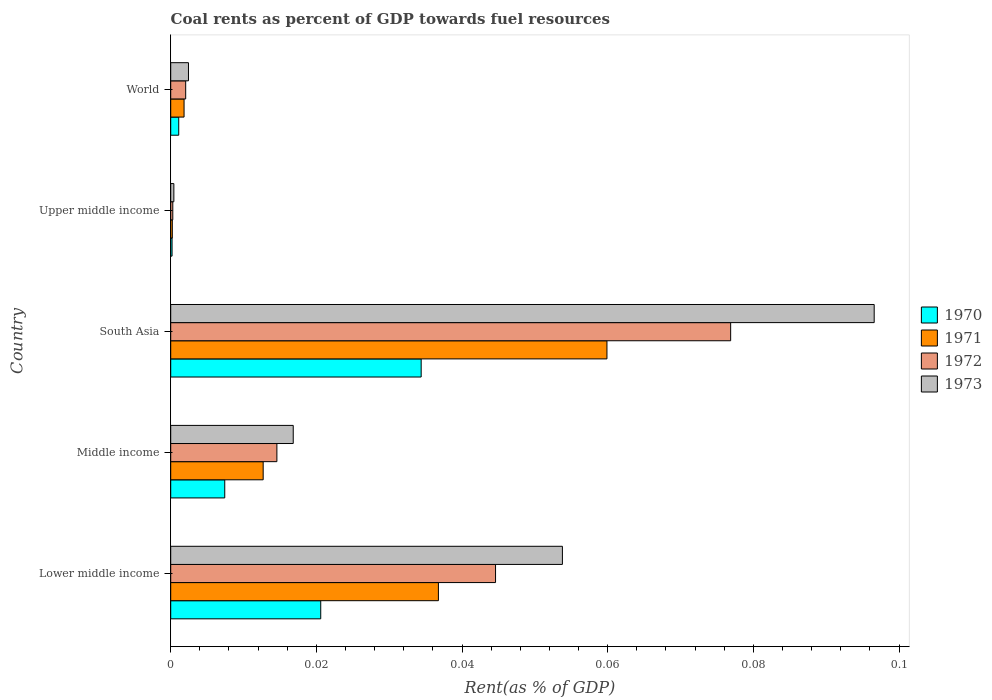Are the number of bars per tick equal to the number of legend labels?
Give a very brief answer. Yes. How many bars are there on the 5th tick from the top?
Your answer should be compact. 4. What is the label of the 2nd group of bars from the top?
Keep it short and to the point. Upper middle income. What is the coal rent in 1971 in World?
Make the answer very short. 0. Across all countries, what is the maximum coal rent in 1970?
Keep it short and to the point. 0.03. Across all countries, what is the minimum coal rent in 1972?
Your response must be concise. 0. In which country was the coal rent in 1972 minimum?
Your answer should be compact. Upper middle income. What is the total coal rent in 1973 in the graph?
Your response must be concise. 0.17. What is the difference between the coal rent in 1970 in Middle income and that in South Asia?
Ensure brevity in your answer.  -0.03. What is the difference between the coal rent in 1970 in Lower middle income and the coal rent in 1971 in Upper middle income?
Your answer should be compact. 0.02. What is the average coal rent in 1972 per country?
Provide a short and direct response. 0.03. What is the difference between the coal rent in 1972 and coal rent in 1970 in Lower middle income?
Your response must be concise. 0.02. In how many countries, is the coal rent in 1973 greater than 0.088 %?
Keep it short and to the point. 1. What is the ratio of the coal rent in 1971 in Middle income to that in South Asia?
Provide a short and direct response. 0.21. What is the difference between the highest and the second highest coal rent in 1971?
Your response must be concise. 0.02. What is the difference between the highest and the lowest coal rent in 1972?
Keep it short and to the point. 0.08. In how many countries, is the coal rent in 1970 greater than the average coal rent in 1970 taken over all countries?
Your answer should be compact. 2. Is the sum of the coal rent in 1971 in Middle income and Upper middle income greater than the maximum coal rent in 1973 across all countries?
Your answer should be compact. No. Is it the case that in every country, the sum of the coal rent in 1970 and coal rent in 1972 is greater than the coal rent in 1971?
Your answer should be very brief. Yes. Are the values on the major ticks of X-axis written in scientific E-notation?
Give a very brief answer. No. How many legend labels are there?
Keep it short and to the point. 4. How are the legend labels stacked?
Give a very brief answer. Vertical. What is the title of the graph?
Provide a short and direct response. Coal rents as percent of GDP towards fuel resources. Does "1972" appear as one of the legend labels in the graph?
Your answer should be compact. Yes. What is the label or title of the X-axis?
Your answer should be very brief. Rent(as % of GDP). What is the Rent(as % of GDP) in 1970 in Lower middle income?
Provide a short and direct response. 0.02. What is the Rent(as % of GDP) in 1971 in Lower middle income?
Offer a very short reply. 0.04. What is the Rent(as % of GDP) in 1972 in Lower middle income?
Your answer should be compact. 0.04. What is the Rent(as % of GDP) in 1973 in Lower middle income?
Ensure brevity in your answer.  0.05. What is the Rent(as % of GDP) in 1970 in Middle income?
Offer a very short reply. 0.01. What is the Rent(as % of GDP) in 1971 in Middle income?
Ensure brevity in your answer.  0.01. What is the Rent(as % of GDP) of 1972 in Middle income?
Your answer should be compact. 0.01. What is the Rent(as % of GDP) of 1973 in Middle income?
Make the answer very short. 0.02. What is the Rent(as % of GDP) in 1970 in South Asia?
Keep it short and to the point. 0.03. What is the Rent(as % of GDP) in 1971 in South Asia?
Your answer should be very brief. 0.06. What is the Rent(as % of GDP) of 1972 in South Asia?
Make the answer very short. 0.08. What is the Rent(as % of GDP) in 1973 in South Asia?
Give a very brief answer. 0.1. What is the Rent(as % of GDP) of 1970 in Upper middle income?
Offer a very short reply. 0. What is the Rent(as % of GDP) in 1971 in Upper middle income?
Offer a terse response. 0. What is the Rent(as % of GDP) of 1972 in Upper middle income?
Your answer should be very brief. 0. What is the Rent(as % of GDP) of 1973 in Upper middle income?
Offer a terse response. 0. What is the Rent(as % of GDP) of 1970 in World?
Your answer should be compact. 0. What is the Rent(as % of GDP) of 1971 in World?
Offer a terse response. 0. What is the Rent(as % of GDP) in 1972 in World?
Keep it short and to the point. 0. What is the Rent(as % of GDP) in 1973 in World?
Your response must be concise. 0. Across all countries, what is the maximum Rent(as % of GDP) of 1970?
Your response must be concise. 0.03. Across all countries, what is the maximum Rent(as % of GDP) of 1971?
Provide a short and direct response. 0.06. Across all countries, what is the maximum Rent(as % of GDP) of 1972?
Make the answer very short. 0.08. Across all countries, what is the maximum Rent(as % of GDP) of 1973?
Your answer should be compact. 0.1. Across all countries, what is the minimum Rent(as % of GDP) in 1970?
Ensure brevity in your answer.  0. Across all countries, what is the minimum Rent(as % of GDP) of 1971?
Make the answer very short. 0. Across all countries, what is the minimum Rent(as % of GDP) in 1972?
Offer a terse response. 0. Across all countries, what is the minimum Rent(as % of GDP) of 1973?
Make the answer very short. 0. What is the total Rent(as % of GDP) of 1970 in the graph?
Your answer should be compact. 0.06. What is the total Rent(as % of GDP) in 1971 in the graph?
Your response must be concise. 0.11. What is the total Rent(as % of GDP) in 1972 in the graph?
Your answer should be compact. 0.14. What is the total Rent(as % of GDP) in 1973 in the graph?
Provide a succinct answer. 0.17. What is the difference between the Rent(as % of GDP) of 1970 in Lower middle income and that in Middle income?
Provide a succinct answer. 0.01. What is the difference between the Rent(as % of GDP) of 1971 in Lower middle income and that in Middle income?
Keep it short and to the point. 0.02. What is the difference between the Rent(as % of GDP) in 1972 in Lower middle income and that in Middle income?
Provide a short and direct response. 0.03. What is the difference between the Rent(as % of GDP) of 1973 in Lower middle income and that in Middle income?
Your answer should be very brief. 0.04. What is the difference between the Rent(as % of GDP) of 1970 in Lower middle income and that in South Asia?
Give a very brief answer. -0.01. What is the difference between the Rent(as % of GDP) of 1971 in Lower middle income and that in South Asia?
Your answer should be compact. -0.02. What is the difference between the Rent(as % of GDP) in 1972 in Lower middle income and that in South Asia?
Offer a terse response. -0.03. What is the difference between the Rent(as % of GDP) in 1973 in Lower middle income and that in South Asia?
Your response must be concise. -0.04. What is the difference between the Rent(as % of GDP) of 1970 in Lower middle income and that in Upper middle income?
Provide a short and direct response. 0.02. What is the difference between the Rent(as % of GDP) of 1971 in Lower middle income and that in Upper middle income?
Ensure brevity in your answer.  0.04. What is the difference between the Rent(as % of GDP) of 1972 in Lower middle income and that in Upper middle income?
Provide a succinct answer. 0.04. What is the difference between the Rent(as % of GDP) in 1973 in Lower middle income and that in Upper middle income?
Offer a terse response. 0.05. What is the difference between the Rent(as % of GDP) of 1970 in Lower middle income and that in World?
Your answer should be very brief. 0.02. What is the difference between the Rent(as % of GDP) in 1971 in Lower middle income and that in World?
Your answer should be compact. 0.03. What is the difference between the Rent(as % of GDP) in 1972 in Lower middle income and that in World?
Provide a succinct answer. 0.04. What is the difference between the Rent(as % of GDP) in 1973 in Lower middle income and that in World?
Make the answer very short. 0.05. What is the difference between the Rent(as % of GDP) of 1970 in Middle income and that in South Asia?
Give a very brief answer. -0.03. What is the difference between the Rent(as % of GDP) in 1971 in Middle income and that in South Asia?
Your answer should be compact. -0.05. What is the difference between the Rent(as % of GDP) in 1972 in Middle income and that in South Asia?
Offer a very short reply. -0.06. What is the difference between the Rent(as % of GDP) of 1973 in Middle income and that in South Asia?
Give a very brief answer. -0.08. What is the difference between the Rent(as % of GDP) of 1970 in Middle income and that in Upper middle income?
Your answer should be compact. 0.01. What is the difference between the Rent(as % of GDP) of 1971 in Middle income and that in Upper middle income?
Your answer should be compact. 0.01. What is the difference between the Rent(as % of GDP) in 1972 in Middle income and that in Upper middle income?
Your response must be concise. 0.01. What is the difference between the Rent(as % of GDP) of 1973 in Middle income and that in Upper middle income?
Your response must be concise. 0.02. What is the difference between the Rent(as % of GDP) in 1970 in Middle income and that in World?
Offer a very short reply. 0.01. What is the difference between the Rent(as % of GDP) of 1971 in Middle income and that in World?
Your answer should be very brief. 0.01. What is the difference between the Rent(as % of GDP) in 1972 in Middle income and that in World?
Provide a short and direct response. 0.01. What is the difference between the Rent(as % of GDP) in 1973 in Middle income and that in World?
Your answer should be compact. 0.01. What is the difference between the Rent(as % of GDP) in 1970 in South Asia and that in Upper middle income?
Your response must be concise. 0.03. What is the difference between the Rent(as % of GDP) of 1971 in South Asia and that in Upper middle income?
Ensure brevity in your answer.  0.06. What is the difference between the Rent(as % of GDP) of 1972 in South Asia and that in Upper middle income?
Offer a terse response. 0.08. What is the difference between the Rent(as % of GDP) in 1973 in South Asia and that in Upper middle income?
Provide a short and direct response. 0.1. What is the difference between the Rent(as % of GDP) of 1971 in South Asia and that in World?
Give a very brief answer. 0.06. What is the difference between the Rent(as % of GDP) of 1972 in South Asia and that in World?
Offer a very short reply. 0.07. What is the difference between the Rent(as % of GDP) of 1973 in South Asia and that in World?
Offer a very short reply. 0.09. What is the difference between the Rent(as % of GDP) of 1970 in Upper middle income and that in World?
Your response must be concise. -0. What is the difference between the Rent(as % of GDP) of 1971 in Upper middle income and that in World?
Offer a very short reply. -0. What is the difference between the Rent(as % of GDP) in 1972 in Upper middle income and that in World?
Your answer should be very brief. -0. What is the difference between the Rent(as % of GDP) in 1973 in Upper middle income and that in World?
Your answer should be compact. -0. What is the difference between the Rent(as % of GDP) in 1970 in Lower middle income and the Rent(as % of GDP) in 1971 in Middle income?
Offer a very short reply. 0.01. What is the difference between the Rent(as % of GDP) of 1970 in Lower middle income and the Rent(as % of GDP) of 1972 in Middle income?
Provide a short and direct response. 0.01. What is the difference between the Rent(as % of GDP) of 1970 in Lower middle income and the Rent(as % of GDP) of 1973 in Middle income?
Keep it short and to the point. 0. What is the difference between the Rent(as % of GDP) of 1971 in Lower middle income and the Rent(as % of GDP) of 1972 in Middle income?
Give a very brief answer. 0.02. What is the difference between the Rent(as % of GDP) in 1971 in Lower middle income and the Rent(as % of GDP) in 1973 in Middle income?
Give a very brief answer. 0.02. What is the difference between the Rent(as % of GDP) of 1972 in Lower middle income and the Rent(as % of GDP) of 1973 in Middle income?
Your answer should be compact. 0.03. What is the difference between the Rent(as % of GDP) in 1970 in Lower middle income and the Rent(as % of GDP) in 1971 in South Asia?
Your response must be concise. -0.04. What is the difference between the Rent(as % of GDP) in 1970 in Lower middle income and the Rent(as % of GDP) in 1972 in South Asia?
Provide a short and direct response. -0.06. What is the difference between the Rent(as % of GDP) of 1970 in Lower middle income and the Rent(as % of GDP) of 1973 in South Asia?
Provide a succinct answer. -0.08. What is the difference between the Rent(as % of GDP) of 1971 in Lower middle income and the Rent(as % of GDP) of 1972 in South Asia?
Make the answer very short. -0.04. What is the difference between the Rent(as % of GDP) of 1971 in Lower middle income and the Rent(as % of GDP) of 1973 in South Asia?
Keep it short and to the point. -0.06. What is the difference between the Rent(as % of GDP) of 1972 in Lower middle income and the Rent(as % of GDP) of 1973 in South Asia?
Your answer should be compact. -0.05. What is the difference between the Rent(as % of GDP) in 1970 in Lower middle income and the Rent(as % of GDP) in 1971 in Upper middle income?
Your response must be concise. 0.02. What is the difference between the Rent(as % of GDP) of 1970 in Lower middle income and the Rent(as % of GDP) of 1972 in Upper middle income?
Keep it short and to the point. 0.02. What is the difference between the Rent(as % of GDP) in 1970 in Lower middle income and the Rent(as % of GDP) in 1973 in Upper middle income?
Your response must be concise. 0.02. What is the difference between the Rent(as % of GDP) of 1971 in Lower middle income and the Rent(as % of GDP) of 1972 in Upper middle income?
Keep it short and to the point. 0.04. What is the difference between the Rent(as % of GDP) of 1971 in Lower middle income and the Rent(as % of GDP) of 1973 in Upper middle income?
Your answer should be compact. 0.04. What is the difference between the Rent(as % of GDP) of 1972 in Lower middle income and the Rent(as % of GDP) of 1973 in Upper middle income?
Your response must be concise. 0.04. What is the difference between the Rent(as % of GDP) in 1970 in Lower middle income and the Rent(as % of GDP) in 1971 in World?
Your response must be concise. 0.02. What is the difference between the Rent(as % of GDP) in 1970 in Lower middle income and the Rent(as % of GDP) in 1972 in World?
Offer a terse response. 0.02. What is the difference between the Rent(as % of GDP) of 1970 in Lower middle income and the Rent(as % of GDP) of 1973 in World?
Your answer should be compact. 0.02. What is the difference between the Rent(as % of GDP) in 1971 in Lower middle income and the Rent(as % of GDP) in 1972 in World?
Keep it short and to the point. 0.03. What is the difference between the Rent(as % of GDP) of 1971 in Lower middle income and the Rent(as % of GDP) of 1973 in World?
Provide a succinct answer. 0.03. What is the difference between the Rent(as % of GDP) of 1972 in Lower middle income and the Rent(as % of GDP) of 1973 in World?
Your answer should be very brief. 0.04. What is the difference between the Rent(as % of GDP) in 1970 in Middle income and the Rent(as % of GDP) in 1971 in South Asia?
Offer a terse response. -0.05. What is the difference between the Rent(as % of GDP) in 1970 in Middle income and the Rent(as % of GDP) in 1972 in South Asia?
Your answer should be very brief. -0.07. What is the difference between the Rent(as % of GDP) in 1970 in Middle income and the Rent(as % of GDP) in 1973 in South Asia?
Offer a very short reply. -0.09. What is the difference between the Rent(as % of GDP) of 1971 in Middle income and the Rent(as % of GDP) of 1972 in South Asia?
Ensure brevity in your answer.  -0.06. What is the difference between the Rent(as % of GDP) of 1971 in Middle income and the Rent(as % of GDP) of 1973 in South Asia?
Keep it short and to the point. -0.08. What is the difference between the Rent(as % of GDP) in 1972 in Middle income and the Rent(as % of GDP) in 1973 in South Asia?
Your answer should be compact. -0.08. What is the difference between the Rent(as % of GDP) in 1970 in Middle income and the Rent(as % of GDP) in 1971 in Upper middle income?
Keep it short and to the point. 0.01. What is the difference between the Rent(as % of GDP) in 1970 in Middle income and the Rent(as % of GDP) in 1972 in Upper middle income?
Offer a very short reply. 0.01. What is the difference between the Rent(as % of GDP) in 1970 in Middle income and the Rent(as % of GDP) in 1973 in Upper middle income?
Keep it short and to the point. 0.01. What is the difference between the Rent(as % of GDP) in 1971 in Middle income and the Rent(as % of GDP) in 1972 in Upper middle income?
Offer a terse response. 0.01. What is the difference between the Rent(as % of GDP) in 1971 in Middle income and the Rent(as % of GDP) in 1973 in Upper middle income?
Offer a very short reply. 0.01. What is the difference between the Rent(as % of GDP) of 1972 in Middle income and the Rent(as % of GDP) of 1973 in Upper middle income?
Your response must be concise. 0.01. What is the difference between the Rent(as % of GDP) in 1970 in Middle income and the Rent(as % of GDP) in 1971 in World?
Provide a succinct answer. 0.01. What is the difference between the Rent(as % of GDP) of 1970 in Middle income and the Rent(as % of GDP) of 1972 in World?
Provide a succinct answer. 0.01. What is the difference between the Rent(as % of GDP) of 1970 in Middle income and the Rent(as % of GDP) of 1973 in World?
Provide a succinct answer. 0.01. What is the difference between the Rent(as % of GDP) of 1971 in Middle income and the Rent(as % of GDP) of 1972 in World?
Offer a terse response. 0.01. What is the difference between the Rent(as % of GDP) of 1971 in Middle income and the Rent(as % of GDP) of 1973 in World?
Your answer should be very brief. 0.01. What is the difference between the Rent(as % of GDP) in 1972 in Middle income and the Rent(as % of GDP) in 1973 in World?
Provide a short and direct response. 0.01. What is the difference between the Rent(as % of GDP) of 1970 in South Asia and the Rent(as % of GDP) of 1971 in Upper middle income?
Ensure brevity in your answer.  0.03. What is the difference between the Rent(as % of GDP) of 1970 in South Asia and the Rent(as % of GDP) of 1972 in Upper middle income?
Your answer should be very brief. 0.03. What is the difference between the Rent(as % of GDP) of 1970 in South Asia and the Rent(as % of GDP) of 1973 in Upper middle income?
Give a very brief answer. 0.03. What is the difference between the Rent(as % of GDP) in 1971 in South Asia and the Rent(as % of GDP) in 1972 in Upper middle income?
Make the answer very short. 0.06. What is the difference between the Rent(as % of GDP) of 1971 in South Asia and the Rent(as % of GDP) of 1973 in Upper middle income?
Offer a terse response. 0.06. What is the difference between the Rent(as % of GDP) of 1972 in South Asia and the Rent(as % of GDP) of 1973 in Upper middle income?
Provide a succinct answer. 0.08. What is the difference between the Rent(as % of GDP) of 1970 in South Asia and the Rent(as % of GDP) of 1971 in World?
Give a very brief answer. 0.03. What is the difference between the Rent(as % of GDP) in 1970 in South Asia and the Rent(as % of GDP) in 1972 in World?
Give a very brief answer. 0.03. What is the difference between the Rent(as % of GDP) in 1970 in South Asia and the Rent(as % of GDP) in 1973 in World?
Offer a very short reply. 0.03. What is the difference between the Rent(as % of GDP) of 1971 in South Asia and the Rent(as % of GDP) of 1972 in World?
Keep it short and to the point. 0.06. What is the difference between the Rent(as % of GDP) in 1971 in South Asia and the Rent(as % of GDP) in 1973 in World?
Offer a very short reply. 0.06. What is the difference between the Rent(as % of GDP) in 1972 in South Asia and the Rent(as % of GDP) in 1973 in World?
Provide a short and direct response. 0.07. What is the difference between the Rent(as % of GDP) of 1970 in Upper middle income and the Rent(as % of GDP) of 1971 in World?
Ensure brevity in your answer.  -0. What is the difference between the Rent(as % of GDP) of 1970 in Upper middle income and the Rent(as % of GDP) of 1972 in World?
Offer a terse response. -0. What is the difference between the Rent(as % of GDP) in 1970 in Upper middle income and the Rent(as % of GDP) in 1973 in World?
Your answer should be very brief. -0. What is the difference between the Rent(as % of GDP) in 1971 in Upper middle income and the Rent(as % of GDP) in 1972 in World?
Ensure brevity in your answer.  -0. What is the difference between the Rent(as % of GDP) in 1971 in Upper middle income and the Rent(as % of GDP) in 1973 in World?
Your response must be concise. -0. What is the difference between the Rent(as % of GDP) in 1972 in Upper middle income and the Rent(as % of GDP) in 1973 in World?
Keep it short and to the point. -0. What is the average Rent(as % of GDP) of 1970 per country?
Offer a terse response. 0.01. What is the average Rent(as % of GDP) in 1971 per country?
Offer a terse response. 0.02. What is the average Rent(as % of GDP) of 1972 per country?
Ensure brevity in your answer.  0.03. What is the average Rent(as % of GDP) of 1973 per country?
Offer a very short reply. 0.03. What is the difference between the Rent(as % of GDP) in 1970 and Rent(as % of GDP) in 1971 in Lower middle income?
Ensure brevity in your answer.  -0.02. What is the difference between the Rent(as % of GDP) of 1970 and Rent(as % of GDP) of 1972 in Lower middle income?
Provide a succinct answer. -0.02. What is the difference between the Rent(as % of GDP) in 1970 and Rent(as % of GDP) in 1973 in Lower middle income?
Your response must be concise. -0.03. What is the difference between the Rent(as % of GDP) of 1971 and Rent(as % of GDP) of 1972 in Lower middle income?
Give a very brief answer. -0.01. What is the difference between the Rent(as % of GDP) of 1971 and Rent(as % of GDP) of 1973 in Lower middle income?
Your answer should be compact. -0.02. What is the difference between the Rent(as % of GDP) in 1972 and Rent(as % of GDP) in 1973 in Lower middle income?
Your answer should be compact. -0.01. What is the difference between the Rent(as % of GDP) in 1970 and Rent(as % of GDP) in 1971 in Middle income?
Your answer should be compact. -0.01. What is the difference between the Rent(as % of GDP) of 1970 and Rent(as % of GDP) of 1972 in Middle income?
Give a very brief answer. -0.01. What is the difference between the Rent(as % of GDP) of 1970 and Rent(as % of GDP) of 1973 in Middle income?
Ensure brevity in your answer.  -0.01. What is the difference between the Rent(as % of GDP) in 1971 and Rent(as % of GDP) in 1972 in Middle income?
Provide a short and direct response. -0. What is the difference between the Rent(as % of GDP) of 1971 and Rent(as % of GDP) of 1973 in Middle income?
Your response must be concise. -0. What is the difference between the Rent(as % of GDP) of 1972 and Rent(as % of GDP) of 1973 in Middle income?
Ensure brevity in your answer.  -0. What is the difference between the Rent(as % of GDP) in 1970 and Rent(as % of GDP) in 1971 in South Asia?
Give a very brief answer. -0.03. What is the difference between the Rent(as % of GDP) in 1970 and Rent(as % of GDP) in 1972 in South Asia?
Offer a terse response. -0.04. What is the difference between the Rent(as % of GDP) in 1970 and Rent(as % of GDP) in 1973 in South Asia?
Your answer should be compact. -0.06. What is the difference between the Rent(as % of GDP) of 1971 and Rent(as % of GDP) of 1972 in South Asia?
Provide a succinct answer. -0.02. What is the difference between the Rent(as % of GDP) in 1971 and Rent(as % of GDP) in 1973 in South Asia?
Offer a very short reply. -0.04. What is the difference between the Rent(as % of GDP) of 1972 and Rent(as % of GDP) of 1973 in South Asia?
Your answer should be compact. -0.02. What is the difference between the Rent(as % of GDP) in 1970 and Rent(as % of GDP) in 1972 in Upper middle income?
Your answer should be very brief. -0. What is the difference between the Rent(as % of GDP) of 1970 and Rent(as % of GDP) of 1973 in Upper middle income?
Your answer should be compact. -0. What is the difference between the Rent(as % of GDP) of 1971 and Rent(as % of GDP) of 1972 in Upper middle income?
Your response must be concise. -0. What is the difference between the Rent(as % of GDP) of 1971 and Rent(as % of GDP) of 1973 in Upper middle income?
Give a very brief answer. -0. What is the difference between the Rent(as % of GDP) of 1972 and Rent(as % of GDP) of 1973 in Upper middle income?
Ensure brevity in your answer.  -0. What is the difference between the Rent(as % of GDP) of 1970 and Rent(as % of GDP) of 1971 in World?
Your answer should be very brief. -0. What is the difference between the Rent(as % of GDP) in 1970 and Rent(as % of GDP) in 1972 in World?
Offer a terse response. -0. What is the difference between the Rent(as % of GDP) of 1970 and Rent(as % of GDP) of 1973 in World?
Give a very brief answer. -0. What is the difference between the Rent(as % of GDP) of 1971 and Rent(as % of GDP) of 1972 in World?
Offer a terse response. -0. What is the difference between the Rent(as % of GDP) of 1971 and Rent(as % of GDP) of 1973 in World?
Ensure brevity in your answer.  -0. What is the difference between the Rent(as % of GDP) in 1972 and Rent(as % of GDP) in 1973 in World?
Give a very brief answer. -0. What is the ratio of the Rent(as % of GDP) of 1970 in Lower middle income to that in Middle income?
Your answer should be very brief. 2.78. What is the ratio of the Rent(as % of GDP) in 1971 in Lower middle income to that in Middle income?
Ensure brevity in your answer.  2.9. What is the ratio of the Rent(as % of GDP) of 1972 in Lower middle income to that in Middle income?
Offer a terse response. 3.06. What is the ratio of the Rent(as % of GDP) of 1973 in Lower middle income to that in Middle income?
Ensure brevity in your answer.  3.2. What is the ratio of the Rent(as % of GDP) in 1970 in Lower middle income to that in South Asia?
Provide a succinct answer. 0.6. What is the ratio of the Rent(as % of GDP) of 1971 in Lower middle income to that in South Asia?
Keep it short and to the point. 0.61. What is the ratio of the Rent(as % of GDP) of 1972 in Lower middle income to that in South Asia?
Provide a succinct answer. 0.58. What is the ratio of the Rent(as % of GDP) of 1973 in Lower middle income to that in South Asia?
Your answer should be compact. 0.56. What is the ratio of the Rent(as % of GDP) of 1970 in Lower middle income to that in Upper middle income?
Provide a succinct answer. 112.03. What is the ratio of the Rent(as % of GDP) of 1971 in Lower middle income to that in Upper middle income?
Offer a very short reply. 167.98. What is the ratio of the Rent(as % of GDP) of 1972 in Lower middle income to that in Upper middle income?
Offer a terse response. 156.82. What is the ratio of the Rent(as % of GDP) in 1973 in Lower middle income to that in Upper middle income?
Provide a short and direct response. 124.82. What is the ratio of the Rent(as % of GDP) of 1970 in Lower middle income to that in World?
Make the answer very short. 18.71. What is the ratio of the Rent(as % of GDP) of 1971 in Lower middle income to that in World?
Provide a short and direct response. 20.06. What is the ratio of the Rent(as % of GDP) in 1972 in Lower middle income to that in World?
Offer a terse response. 21.7. What is the ratio of the Rent(as % of GDP) of 1973 in Lower middle income to that in World?
Offer a very short reply. 22.07. What is the ratio of the Rent(as % of GDP) of 1970 in Middle income to that in South Asia?
Provide a short and direct response. 0.22. What is the ratio of the Rent(as % of GDP) of 1971 in Middle income to that in South Asia?
Keep it short and to the point. 0.21. What is the ratio of the Rent(as % of GDP) in 1972 in Middle income to that in South Asia?
Offer a very short reply. 0.19. What is the ratio of the Rent(as % of GDP) of 1973 in Middle income to that in South Asia?
Your answer should be compact. 0.17. What is the ratio of the Rent(as % of GDP) of 1970 in Middle income to that in Upper middle income?
Keep it short and to the point. 40.36. What is the ratio of the Rent(as % of GDP) in 1971 in Middle income to that in Upper middle income?
Provide a succinct answer. 58.01. What is the ratio of the Rent(as % of GDP) of 1972 in Middle income to that in Upper middle income?
Make the answer very short. 51.25. What is the ratio of the Rent(as % of GDP) in 1973 in Middle income to that in Upper middle income?
Make the answer very short. 39.04. What is the ratio of the Rent(as % of GDP) in 1970 in Middle income to that in World?
Offer a terse response. 6.74. What is the ratio of the Rent(as % of GDP) of 1971 in Middle income to that in World?
Provide a succinct answer. 6.93. What is the ratio of the Rent(as % of GDP) of 1972 in Middle income to that in World?
Your answer should be very brief. 7.09. What is the ratio of the Rent(as % of GDP) of 1973 in Middle income to that in World?
Your response must be concise. 6.91. What is the ratio of the Rent(as % of GDP) of 1970 in South Asia to that in Upper middle income?
Provide a short and direct response. 187.05. What is the ratio of the Rent(as % of GDP) of 1971 in South Asia to that in Upper middle income?
Provide a succinct answer. 273.74. What is the ratio of the Rent(as % of GDP) in 1972 in South Asia to that in Upper middle income?
Make the answer very short. 270.32. What is the ratio of the Rent(as % of GDP) of 1973 in South Asia to that in Upper middle income?
Ensure brevity in your answer.  224.18. What is the ratio of the Rent(as % of GDP) of 1970 in South Asia to that in World?
Offer a very short reply. 31.24. What is the ratio of the Rent(as % of GDP) in 1971 in South Asia to that in World?
Ensure brevity in your answer.  32.69. What is the ratio of the Rent(as % of GDP) of 1972 in South Asia to that in World?
Offer a very short reply. 37.41. What is the ratio of the Rent(as % of GDP) of 1973 in South Asia to that in World?
Offer a very short reply. 39.65. What is the ratio of the Rent(as % of GDP) of 1970 in Upper middle income to that in World?
Your answer should be very brief. 0.17. What is the ratio of the Rent(as % of GDP) in 1971 in Upper middle income to that in World?
Ensure brevity in your answer.  0.12. What is the ratio of the Rent(as % of GDP) in 1972 in Upper middle income to that in World?
Provide a succinct answer. 0.14. What is the ratio of the Rent(as % of GDP) of 1973 in Upper middle income to that in World?
Provide a short and direct response. 0.18. What is the difference between the highest and the second highest Rent(as % of GDP) in 1970?
Your response must be concise. 0.01. What is the difference between the highest and the second highest Rent(as % of GDP) of 1971?
Your answer should be compact. 0.02. What is the difference between the highest and the second highest Rent(as % of GDP) of 1972?
Make the answer very short. 0.03. What is the difference between the highest and the second highest Rent(as % of GDP) of 1973?
Your answer should be very brief. 0.04. What is the difference between the highest and the lowest Rent(as % of GDP) in 1970?
Give a very brief answer. 0.03. What is the difference between the highest and the lowest Rent(as % of GDP) of 1971?
Ensure brevity in your answer.  0.06. What is the difference between the highest and the lowest Rent(as % of GDP) of 1972?
Provide a succinct answer. 0.08. What is the difference between the highest and the lowest Rent(as % of GDP) of 1973?
Offer a terse response. 0.1. 